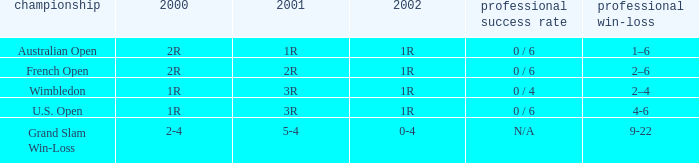Which career win-loss record has a 1r in 2002, a 2r in 2000 and a 2r in 2001? 2–6. 